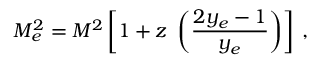<formula> <loc_0><loc_0><loc_500><loc_500>M _ { e } ^ { 2 } = M ^ { 2 } \left [ 1 + z \left ( { \frac { 2 y _ { e } - 1 } { y _ { e } } } \right ) \right ] \, ,</formula> 